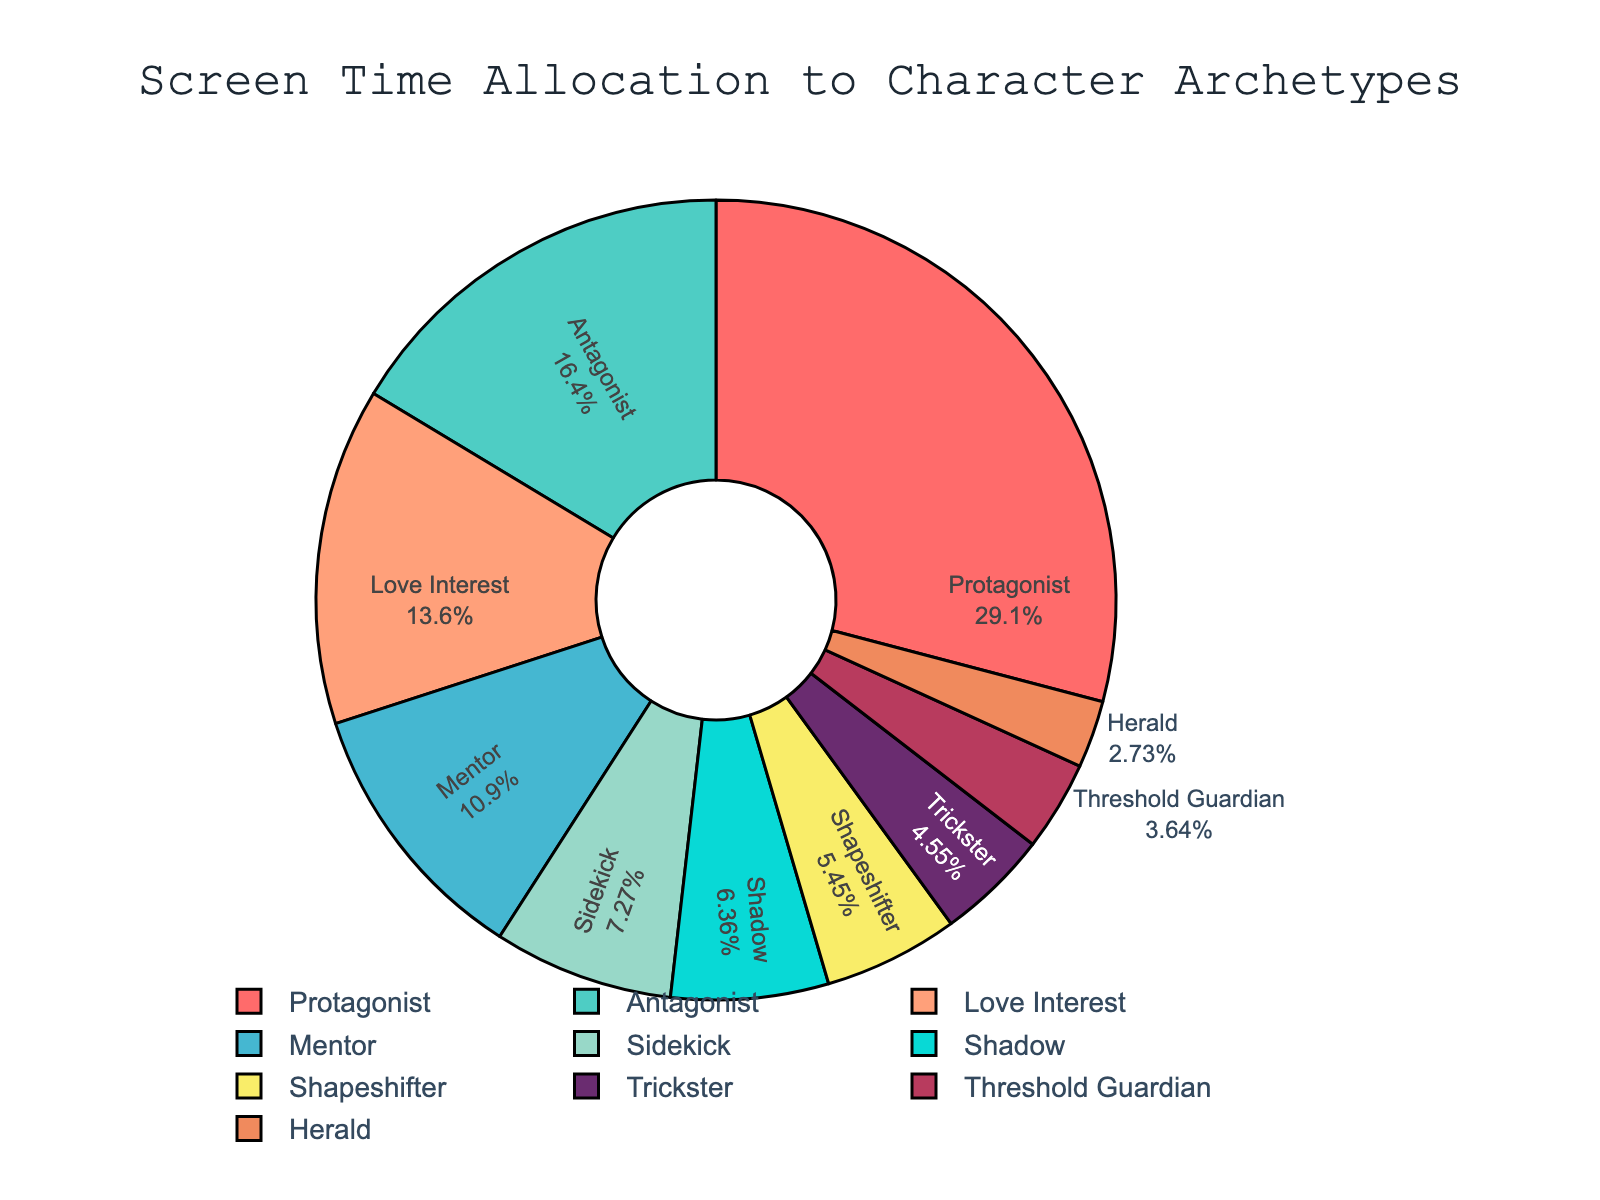Which character archetype receives the highest screen time percentage? The slice that has the largest area represents the Protagonist, with a screen time percentage of 32%.
Answer: Protagonist Which character archetype receives the lowest screen time percentage? The slice with the smallest area represents the Herald, with a screen time percentage of 3%.
Answer: Herald How much more screen time does the Protagonist have compared to the Antagonist? The Protagonist has 32% screen time and the Antagonist has 18%. The difference is calculated as 32% - 18% = 14%.
Answer: 14% What is the combined screen time percentage for Love Interest and Sidekick? The Love Interest has 15% and the Sidekick has 8%. Adding these together gives 15% + 8% = 23%.
Answer: 23% Is the screen time allocated to the Mentor greater than the combined screen time of the Shapeshifter and Trickster? The Mentor has 12% screen time. The Shapeshifter and Trickster together have 6% + 5% = 11%. 12% is greater than 11%.
Answer: Yes How does the screen time of the Shadow compare to that of the Mentor? The Shadow has 7% screen time while the Mentor has 12%. Thus, the Mentor has a larger screen time percentage than the Shadow.
Answer: Mentor has more What percentage of screen time is allocated to characters other than the Protagonist and Antagonist? To find this, subtract the combined screen time of the Protagonist (32%) and Antagonist (18%) from 100%. The result is 100% - (32% + 18%) = 50%.
Answer: 50% Which character archetype shares a similar screen time percentage to the Love Interest? The Love Interest has 15% screen time. The closest archetype is the Antagonist with 18% screen time.
Answer: Antagonist 